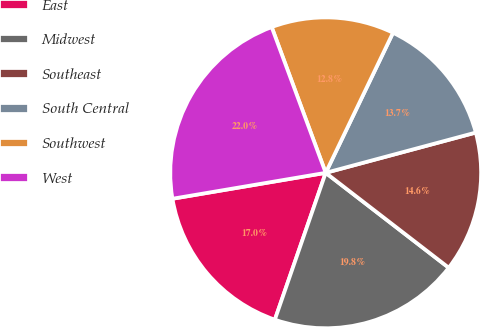<chart> <loc_0><loc_0><loc_500><loc_500><pie_chart><fcel>East<fcel>Midwest<fcel>Southeast<fcel>South Central<fcel>Southwest<fcel>West<nl><fcel>17.03%<fcel>19.85%<fcel>14.63%<fcel>13.7%<fcel>12.78%<fcel>22.02%<nl></chart> 